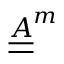Convert formula to latex. <formula><loc_0><loc_0><loc_500><loc_500>\underline { { \underline { A } } } ^ { m }</formula> 